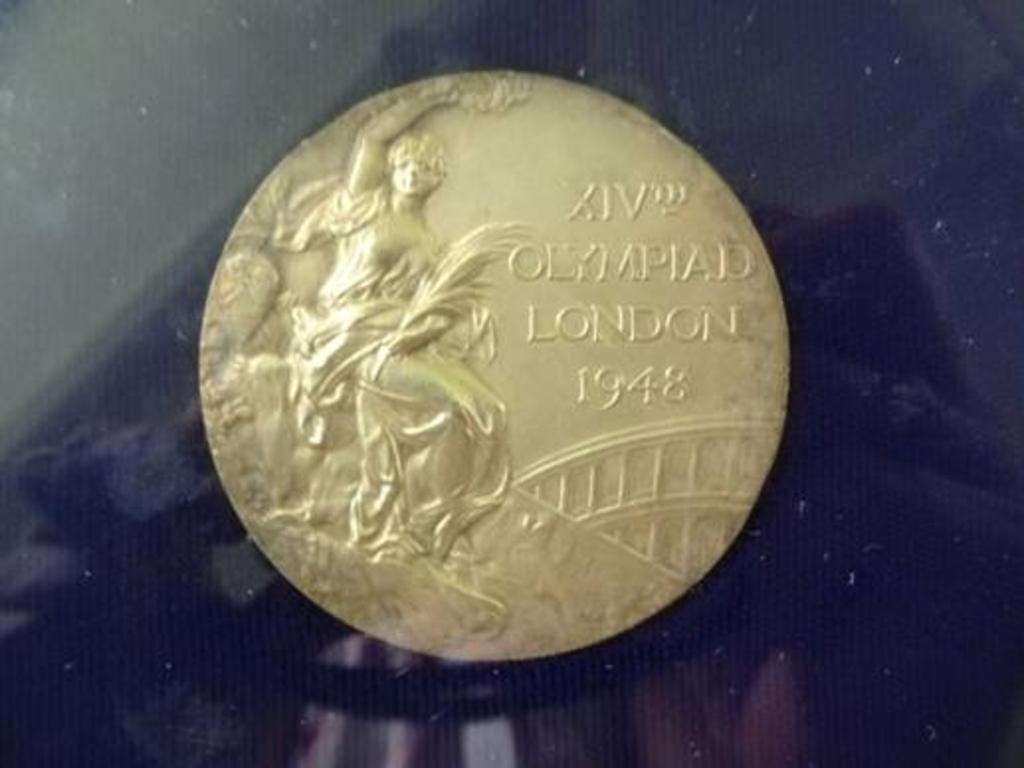<image>
Offer a succinct explanation of the picture presented. A gold coin with the following stamped on it: Olympiad London 1948. 